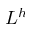Convert formula to latex. <formula><loc_0><loc_0><loc_500><loc_500>L ^ { h }</formula> 